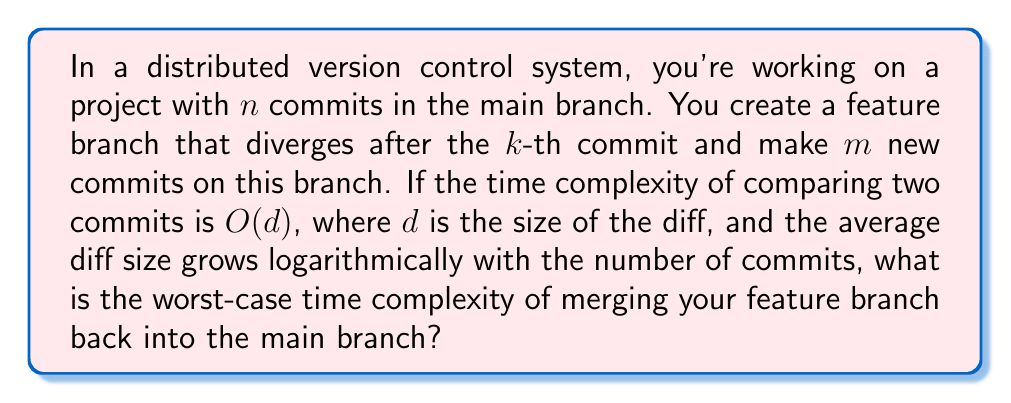Solve this math problem. Let's break this down step by step:

1) In a merge operation, we need to compare each commit in the feature branch with the commits in the main branch that occurred after the branch point.

2) The number of commits in the feature branch is $m$.

3) The number of commits in the main branch after the branch point is $n - k$.

4) For each commit in the feature branch, in the worst case, we need to compare it with all commits in the main branch after the branch point.

5) This gives us a total of $m(n-k)$ comparisons in the worst case.

6) Each comparison has a time complexity of $O(d)$, where $d$ is the size of the diff.

7) We're told that the average diff size grows logarithmically with the number of commits. This means $d = O(\log(n+m))$, as $n+m$ is the total number of commits.

8) Therefore, the time complexity of each comparison is $O(\log(n+m))$.

9) Combining this with the number of comparisons, we get a total time complexity of:

   $$O(m(n-k) \cdot \log(n+m))$$

10) In the worst case, $k$ could be very small (close to 0), giving us:

    $$O(mn \cdot \log(n+m))$$

This is the worst-case time complexity of the merge operation.
Answer: $O(mn \cdot \log(n+m))$ 